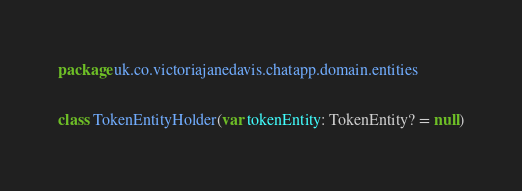<code> <loc_0><loc_0><loc_500><loc_500><_Kotlin_>package uk.co.victoriajanedavis.chatapp.domain.entities

class TokenEntityHolder(var tokenEntity: TokenEntity? = null)</code> 